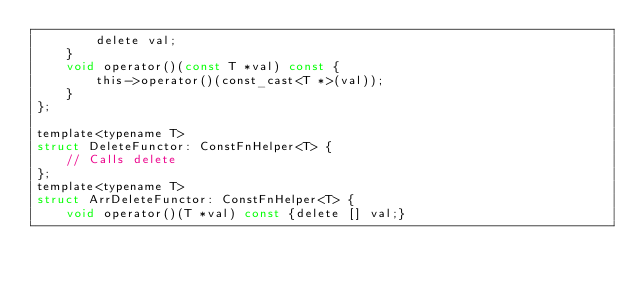<code> <loc_0><loc_0><loc_500><loc_500><_C_>        delete val;
    }
    void operator()(const T *val) const {
        this->operator()(const_cast<T *>(val));
    }
};

template<typename T>
struct DeleteFunctor: ConstFnHelper<T> {
    // Calls delete 
};
template<typename T>
struct ArrDeleteFunctor: ConstFnHelper<T> {
    void operator()(T *val) const {delete [] val;}</code> 